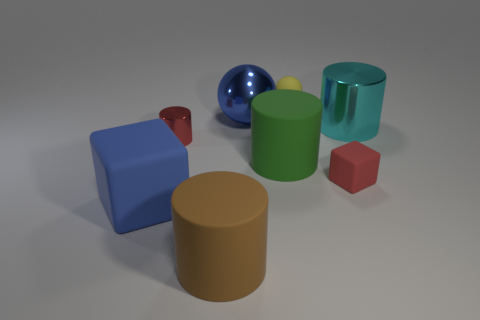Subtract all purple cylinders. Subtract all red balls. How many cylinders are left? 4 Add 1 large purple rubber spheres. How many objects exist? 9 Subtract all spheres. How many objects are left? 6 Add 4 tiny red blocks. How many tiny red blocks exist? 5 Subtract 1 red blocks. How many objects are left? 7 Subtract all tiny yellow spheres. Subtract all yellow rubber spheres. How many objects are left? 6 Add 4 large blue cubes. How many large blue cubes are left? 5 